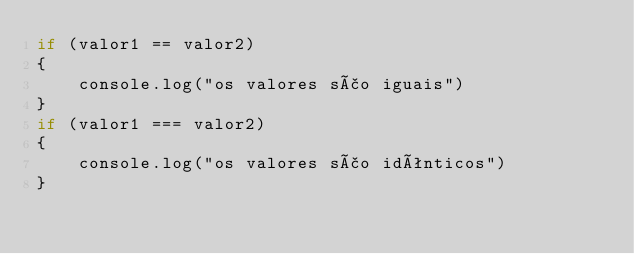Convert code to text. <code><loc_0><loc_0><loc_500><loc_500><_JavaScript_>if (valor1 == valor2)
{
    console.log("os valores são iguais")
}
if (valor1 === valor2)
{
    console.log("os valores são idênticos")
}

</code> 